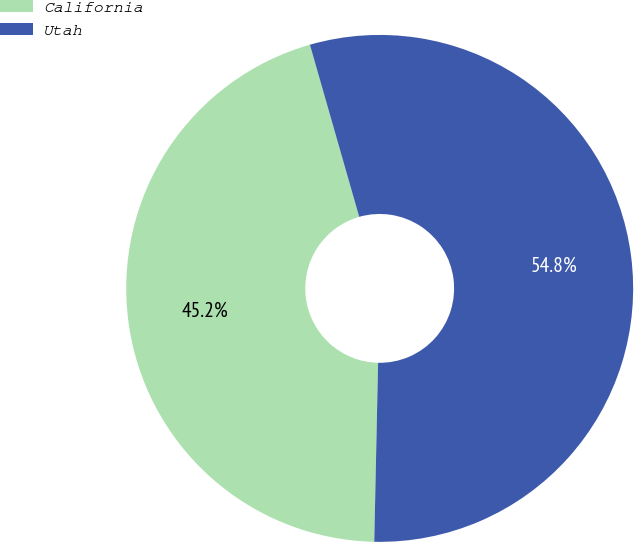<chart> <loc_0><loc_0><loc_500><loc_500><pie_chart><fcel>California<fcel>Utah<nl><fcel>45.22%<fcel>54.78%<nl></chart> 